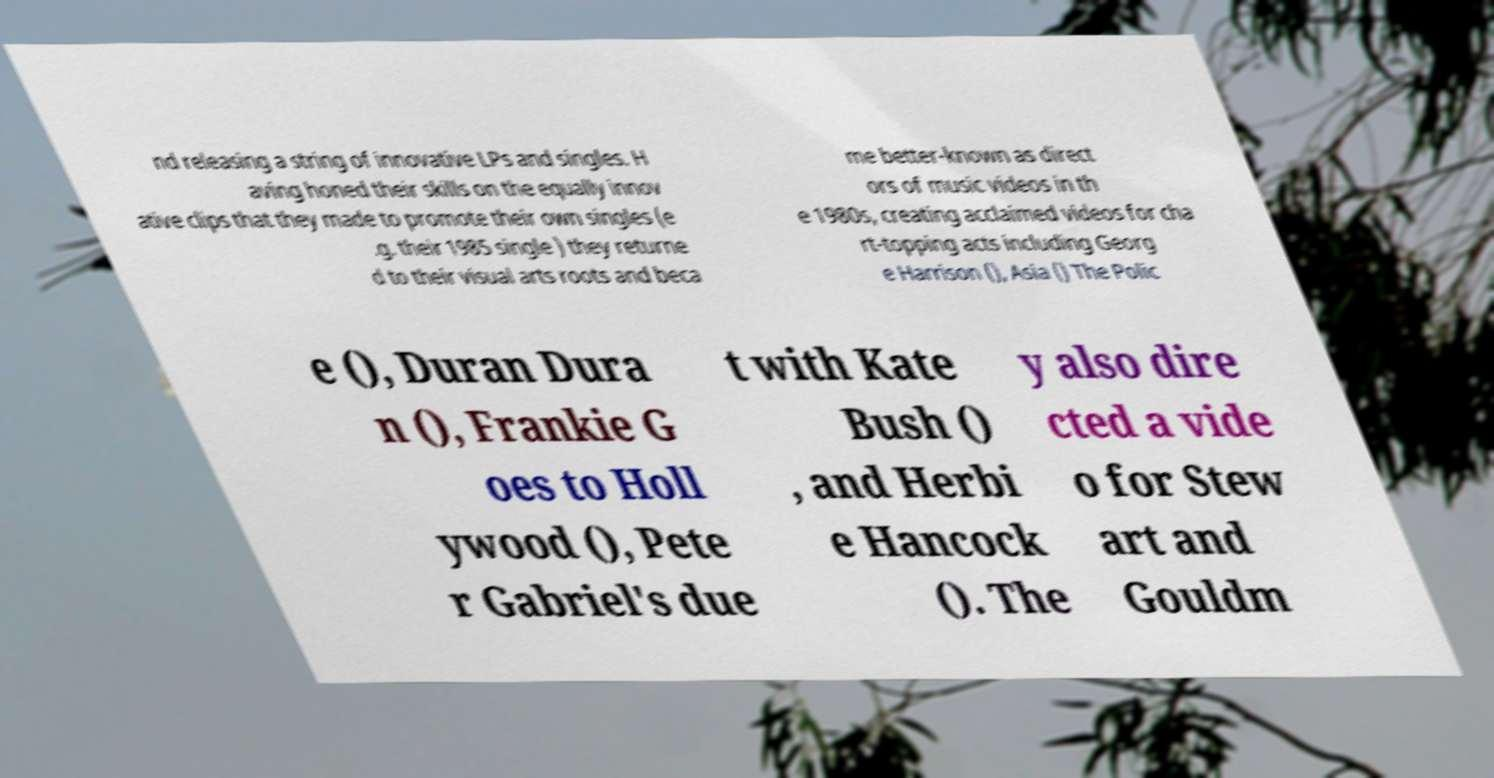Please identify and transcribe the text found in this image. nd releasing a string of innovative LPs and singles. H aving honed their skills on the equally innov ative clips that they made to promote their own singles (e .g. their 1985 single ) they returne d to their visual arts roots and beca me better-known as direct ors of music videos in th e 1980s, creating acclaimed videos for cha rt-topping acts including Georg e Harrison (), Asia () The Polic e (), Duran Dura n (), Frankie G oes to Holl ywood (), Pete r Gabriel's due t with Kate Bush () , and Herbi e Hancock (). The y also dire cted a vide o for Stew art and Gouldm 